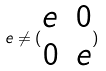<formula> <loc_0><loc_0><loc_500><loc_500>e \ne ( \begin{matrix} e & 0 \\ 0 & e \end{matrix} )</formula> 